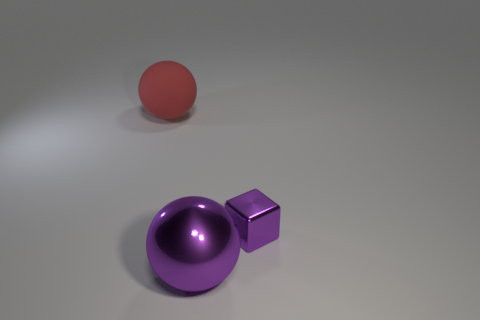Add 3 balls. How many objects exist? 6 Add 1 metal balls. How many metal balls exist? 2 Subtract all purple balls. How many balls are left? 1 Subtract 1 purple balls. How many objects are left? 2 Subtract all blocks. How many objects are left? 2 Subtract 1 cubes. How many cubes are left? 0 Subtract all red blocks. Subtract all cyan balls. How many blocks are left? 1 Subtract all purple cylinders. How many purple balls are left? 1 Subtract all red matte objects. Subtract all large yellow rubber blocks. How many objects are left? 2 Add 3 rubber balls. How many rubber balls are left? 4 